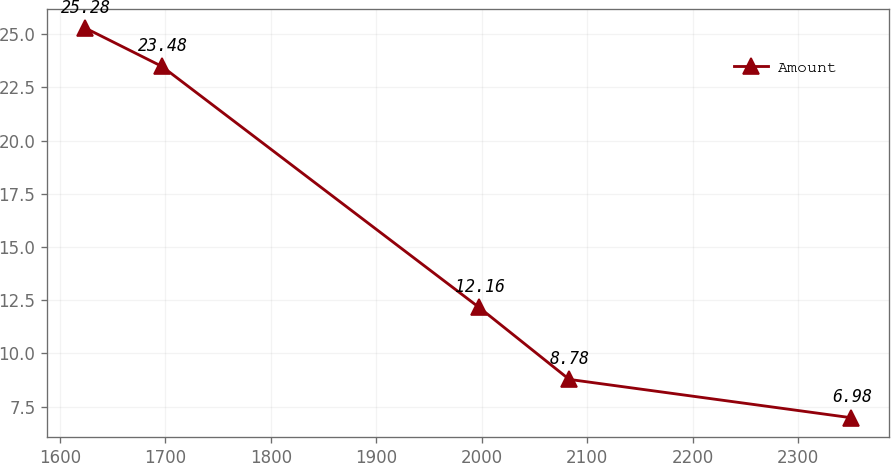Convert chart. <chart><loc_0><loc_0><loc_500><loc_500><line_chart><ecel><fcel>Amount<nl><fcel>1624.4<fcel>25.28<nl><fcel>1696.97<fcel>23.48<nl><fcel>1997.52<fcel>12.16<nl><fcel>2082.93<fcel>8.78<nl><fcel>2350.07<fcel>6.98<nl></chart> 